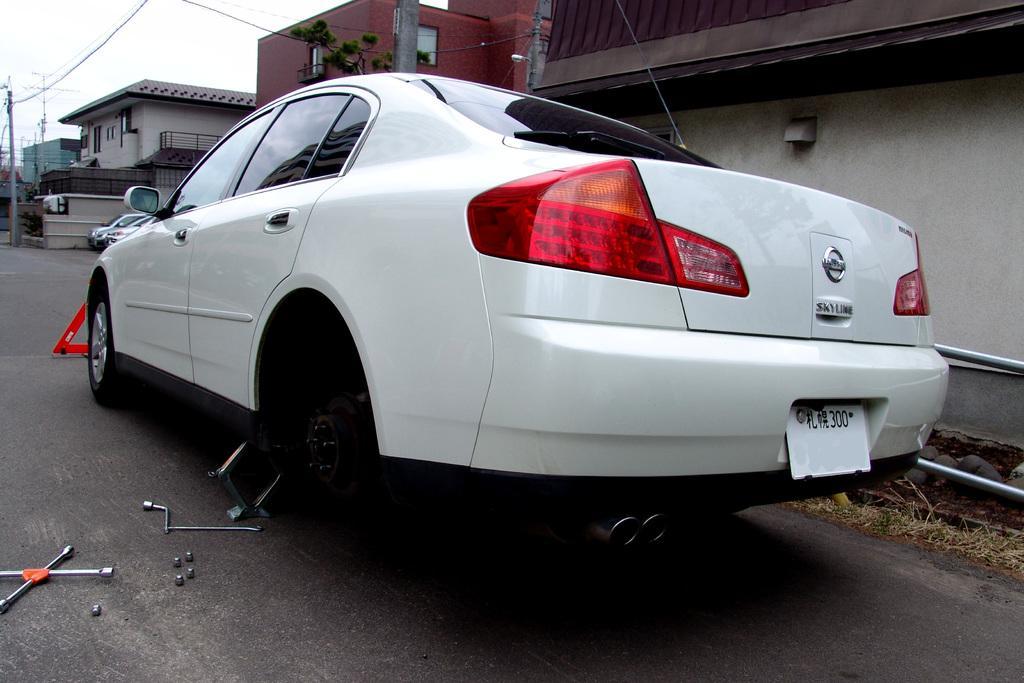How would you summarize this image in a sentence or two? In this image we can see some vehicles on the road, there are some tools, bolts, sign board, also we can see some houses, electric poles with wires, there are some plants, trees, and the grass, we can see the sky. 